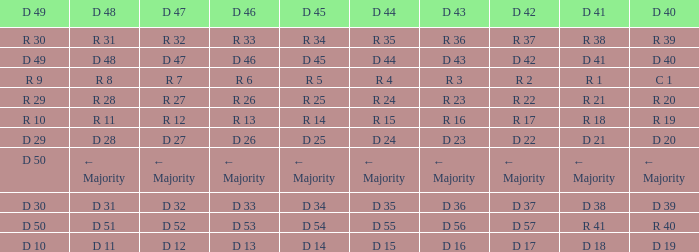Tell me the D 49 and D 46 of r 13 R 10. 